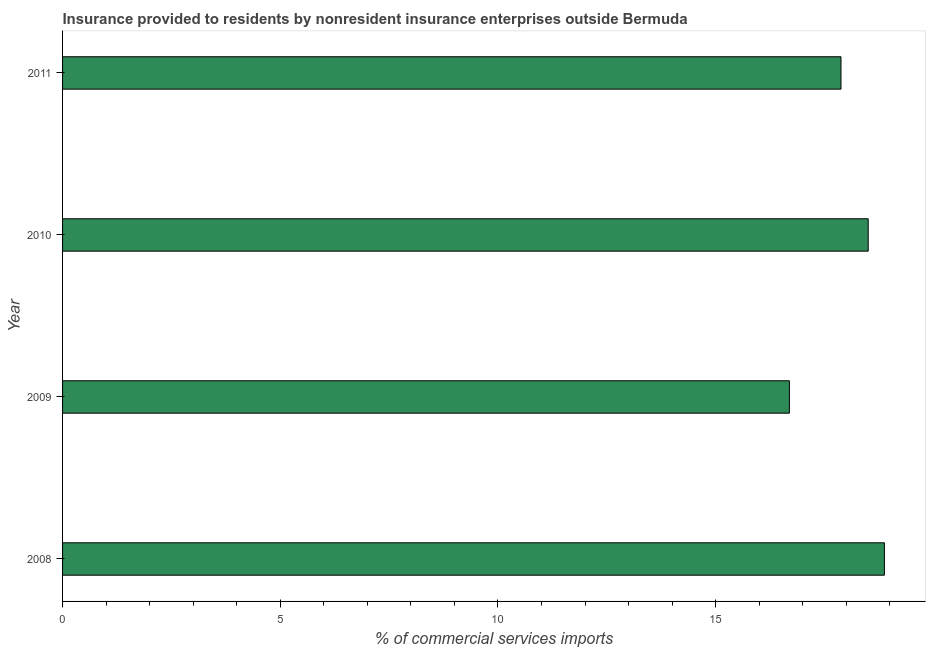Does the graph contain any zero values?
Provide a short and direct response. No. Does the graph contain grids?
Offer a very short reply. No. What is the title of the graph?
Your response must be concise. Insurance provided to residents by nonresident insurance enterprises outside Bermuda. What is the label or title of the X-axis?
Ensure brevity in your answer.  % of commercial services imports. What is the label or title of the Y-axis?
Your answer should be compact. Year. What is the insurance provided by non-residents in 2009?
Your answer should be very brief. 16.69. Across all years, what is the maximum insurance provided by non-residents?
Make the answer very short. 18.87. Across all years, what is the minimum insurance provided by non-residents?
Make the answer very short. 16.69. In which year was the insurance provided by non-residents maximum?
Give a very brief answer. 2008. In which year was the insurance provided by non-residents minimum?
Your answer should be very brief. 2009. What is the sum of the insurance provided by non-residents?
Your response must be concise. 71.95. What is the difference between the insurance provided by non-residents in 2009 and 2011?
Your answer should be compact. -1.19. What is the average insurance provided by non-residents per year?
Offer a very short reply. 17.99. What is the median insurance provided by non-residents?
Keep it short and to the point. 18.19. In how many years, is the insurance provided by non-residents greater than 12 %?
Offer a very short reply. 4. Do a majority of the years between 2008 and 2011 (inclusive) have insurance provided by non-residents greater than 13 %?
Offer a terse response. Yes. What is the ratio of the insurance provided by non-residents in 2008 to that in 2011?
Provide a succinct answer. 1.06. Is the insurance provided by non-residents in 2008 less than that in 2010?
Offer a very short reply. No. Is the difference between the insurance provided by non-residents in 2008 and 2010 greater than the difference between any two years?
Your response must be concise. No. What is the difference between the highest and the second highest insurance provided by non-residents?
Provide a succinct answer. 0.37. Is the sum of the insurance provided by non-residents in 2008 and 2009 greater than the maximum insurance provided by non-residents across all years?
Provide a succinct answer. Yes. What is the difference between the highest and the lowest insurance provided by non-residents?
Ensure brevity in your answer.  2.18. In how many years, is the insurance provided by non-residents greater than the average insurance provided by non-residents taken over all years?
Make the answer very short. 2. How many bars are there?
Your answer should be very brief. 4. What is the % of commercial services imports in 2008?
Make the answer very short. 18.87. What is the % of commercial services imports in 2009?
Your answer should be very brief. 16.69. What is the % of commercial services imports of 2010?
Your answer should be compact. 18.5. What is the % of commercial services imports in 2011?
Ensure brevity in your answer.  17.88. What is the difference between the % of commercial services imports in 2008 and 2009?
Provide a short and direct response. 2.18. What is the difference between the % of commercial services imports in 2008 and 2010?
Offer a very short reply. 0.37. What is the difference between the % of commercial services imports in 2008 and 2011?
Give a very brief answer. 1. What is the difference between the % of commercial services imports in 2009 and 2010?
Your answer should be very brief. -1.81. What is the difference between the % of commercial services imports in 2009 and 2011?
Keep it short and to the point. -1.19. What is the difference between the % of commercial services imports in 2010 and 2011?
Give a very brief answer. 0.63. What is the ratio of the % of commercial services imports in 2008 to that in 2009?
Offer a terse response. 1.13. What is the ratio of the % of commercial services imports in 2008 to that in 2011?
Make the answer very short. 1.06. What is the ratio of the % of commercial services imports in 2009 to that in 2010?
Offer a terse response. 0.9. What is the ratio of the % of commercial services imports in 2009 to that in 2011?
Provide a short and direct response. 0.93. What is the ratio of the % of commercial services imports in 2010 to that in 2011?
Your response must be concise. 1.03. 